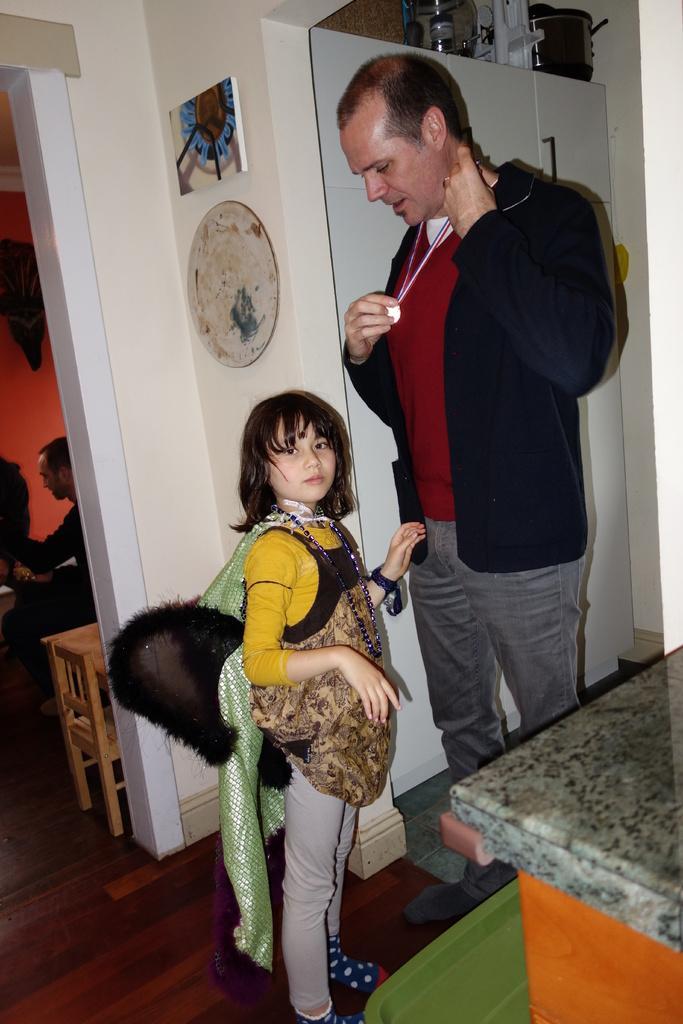Can you describe this image briefly? In the picture I can see a man standing on the floor. He is wearing a jacket and there is a gold medal on his neck. I can see a girl standing on the floor on the left side. I can see the wooden cabinet. I can see a wooden table on the floor. There is another man on the left side. These are looking like paintings on the wall. 